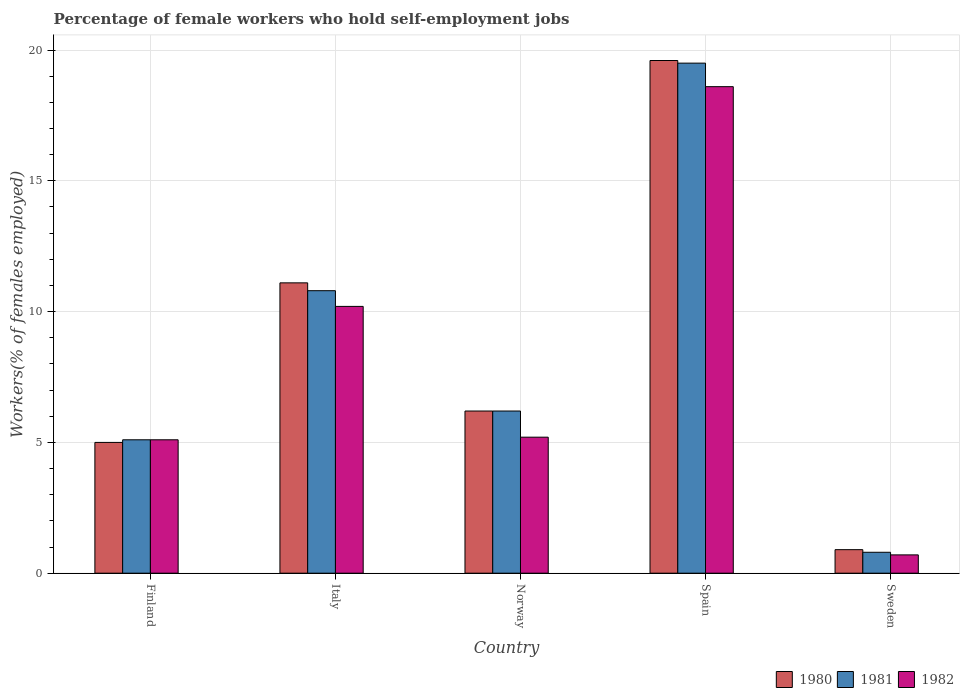How many different coloured bars are there?
Ensure brevity in your answer.  3. How many groups of bars are there?
Keep it short and to the point. 5. Are the number of bars on each tick of the X-axis equal?
Your response must be concise. Yes. How many bars are there on the 5th tick from the right?
Offer a very short reply. 3. What is the percentage of self-employed female workers in 1980 in Italy?
Your answer should be very brief. 11.1. Across all countries, what is the maximum percentage of self-employed female workers in 1981?
Ensure brevity in your answer.  19.5. Across all countries, what is the minimum percentage of self-employed female workers in 1982?
Give a very brief answer. 0.7. What is the total percentage of self-employed female workers in 1981 in the graph?
Keep it short and to the point. 42.4. What is the difference between the percentage of self-employed female workers in 1981 in Finland and that in Sweden?
Your answer should be compact. 4.3. What is the difference between the percentage of self-employed female workers in 1982 in Italy and the percentage of self-employed female workers in 1981 in Sweden?
Keep it short and to the point. 9.4. What is the average percentage of self-employed female workers in 1980 per country?
Provide a short and direct response. 8.56. What is the difference between the percentage of self-employed female workers of/in 1982 and percentage of self-employed female workers of/in 1980 in Italy?
Provide a short and direct response. -0.9. What is the ratio of the percentage of self-employed female workers in 1981 in Norway to that in Spain?
Give a very brief answer. 0.32. What is the difference between the highest and the second highest percentage of self-employed female workers in 1981?
Your answer should be very brief. -8.7. What is the difference between the highest and the lowest percentage of self-employed female workers in 1982?
Offer a terse response. 17.9. In how many countries, is the percentage of self-employed female workers in 1981 greater than the average percentage of self-employed female workers in 1981 taken over all countries?
Give a very brief answer. 2. What does the 2nd bar from the right in Italy represents?
Provide a succinct answer. 1981. Is it the case that in every country, the sum of the percentage of self-employed female workers in 1981 and percentage of self-employed female workers in 1982 is greater than the percentage of self-employed female workers in 1980?
Ensure brevity in your answer.  Yes. How many bars are there?
Make the answer very short. 15. How many legend labels are there?
Your answer should be compact. 3. How are the legend labels stacked?
Provide a short and direct response. Horizontal. What is the title of the graph?
Provide a succinct answer. Percentage of female workers who hold self-employment jobs. What is the label or title of the Y-axis?
Your answer should be very brief. Workers(% of females employed). What is the Workers(% of females employed) in 1981 in Finland?
Keep it short and to the point. 5.1. What is the Workers(% of females employed) of 1982 in Finland?
Give a very brief answer. 5.1. What is the Workers(% of females employed) in 1980 in Italy?
Provide a short and direct response. 11.1. What is the Workers(% of females employed) in 1981 in Italy?
Your answer should be very brief. 10.8. What is the Workers(% of females employed) in 1982 in Italy?
Give a very brief answer. 10.2. What is the Workers(% of females employed) of 1980 in Norway?
Give a very brief answer. 6.2. What is the Workers(% of females employed) of 1981 in Norway?
Provide a short and direct response. 6.2. What is the Workers(% of females employed) in 1982 in Norway?
Keep it short and to the point. 5.2. What is the Workers(% of females employed) of 1980 in Spain?
Your answer should be compact. 19.6. What is the Workers(% of females employed) of 1981 in Spain?
Make the answer very short. 19.5. What is the Workers(% of females employed) in 1982 in Spain?
Offer a terse response. 18.6. What is the Workers(% of females employed) in 1980 in Sweden?
Provide a succinct answer. 0.9. What is the Workers(% of females employed) in 1981 in Sweden?
Your answer should be very brief. 0.8. What is the Workers(% of females employed) of 1982 in Sweden?
Offer a terse response. 0.7. Across all countries, what is the maximum Workers(% of females employed) in 1980?
Your response must be concise. 19.6. Across all countries, what is the maximum Workers(% of females employed) of 1982?
Give a very brief answer. 18.6. Across all countries, what is the minimum Workers(% of females employed) in 1980?
Offer a very short reply. 0.9. Across all countries, what is the minimum Workers(% of females employed) in 1981?
Give a very brief answer. 0.8. Across all countries, what is the minimum Workers(% of females employed) of 1982?
Give a very brief answer. 0.7. What is the total Workers(% of females employed) in 1980 in the graph?
Give a very brief answer. 42.8. What is the total Workers(% of females employed) in 1981 in the graph?
Your answer should be compact. 42.4. What is the total Workers(% of females employed) in 1982 in the graph?
Keep it short and to the point. 39.8. What is the difference between the Workers(% of females employed) of 1981 in Finland and that in Italy?
Offer a terse response. -5.7. What is the difference between the Workers(% of females employed) in 1982 in Finland and that in Italy?
Give a very brief answer. -5.1. What is the difference between the Workers(% of females employed) of 1980 in Finland and that in Norway?
Give a very brief answer. -1.2. What is the difference between the Workers(% of females employed) of 1982 in Finland and that in Norway?
Offer a very short reply. -0.1. What is the difference between the Workers(% of females employed) in 1980 in Finland and that in Spain?
Ensure brevity in your answer.  -14.6. What is the difference between the Workers(% of females employed) of 1981 in Finland and that in Spain?
Ensure brevity in your answer.  -14.4. What is the difference between the Workers(% of females employed) of 1982 in Finland and that in Spain?
Make the answer very short. -13.5. What is the difference between the Workers(% of females employed) in 1980 in Finland and that in Sweden?
Ensure brevity in your answer.  4.1. What is the difference between the Workers(% of females employed) in 1981 in Finland and that in Sweden?
Your answer should be very brief. 4.3. What is the difference between the Workers(% of females employed) of 1982 in Finland and that in Sweden?
Your response must be concise. 4.4. What is the difference between the Workers(% of females employed) of 1980 in Italy and that in Norway?
Keep it short and to the point. 4.9. What is the difference between the Workers(% of females employed) of 1981 in Italy and that in Spain?
Provide a succinct answer. -8.7. What is the difference between the Workers(% of females employed) in 1981 in Italy and that in Sweden?
Provide a succinct answer. 10. What is the difference between the Workers(% of females employed) of 1981 in Norway and that in Spain?
Provide a succinct answer. -13.3. What is the difference between the Workers(% of females employed) in 1981 in Norway and that in Sweden?
Offer a very short reply. 5.4. What is the difference between the Workers(% of females employed) in 1982 in Norway and that in Sweden?
Your response must be concise. 4.5. What is the difference between the Workers(% of females employed) in 1980 in Finland and the Workers(% of females employed) in 1981 in Italy?
Provide a short and direct response. -5.8. What is the difference between the Workers(% of females employed) of 1980 in Finland and the Workers(% of females employed) of 1981 in Norway?
Your response must be concise. -1.2. What is the difference between the Workers(% of females employed) in 1980 in Finland and the Workers(% of females employed) in 1982 in Norway?
Keep it short and to the point. -0.2. What is the difference between the Workers(% of females employed) of 1980 in Finland and the Workers(% of females employed) of 1981 in Spain?
Provide a succinct answer. -14.5. What is the difference between the Workers(% of females employed) of 1981 in Finland and the Workers(% of females employed) of 1982 in Spain?
Make the answer very short. -13.5. What is the difference between the Workers(% of females employed) of 1981 in Finland and the Workers(% of females employed) of 1982 in Sweden?
Your answer should be very brief. 4.4. What is the difference between the Workers(% of females employed) of 1980 in Italy and the Workers(% of females employed) of 1981 in Norway?
Your response must be concise. 4.9. What is the difference between the Workers(% of females employed) of 1980 in Italy and the Workers(% of females employed) of 1982 in Norway?
Give a very brief answer. 5.9. What is the difference between the Workers(% of females employed) of 1980 in Italy and the Workers(% of females employed) of 1982 in Spain?
Your answer should be very brief. -7.5. What is the difference between the Workers(% of females employed) in 1981 in Italy and the Workers(% of females employed) in 1982 in Spain?
Your answer should be compact. -7.8. What is the difference between the Workers(% of females employed) in 1981 in Italy and the Workers(% of females employed) in 1982 in Sweden?
Your answer should be very brief. 10.1. What is the difference between the Workers(% of females employed) of 1980 in Norway and the Workers(% of females employed) of 1981 in Spain?
Ensure brevity in your answer.  -13.3. What is the difference between the Workers(% of females employed) in 1980 in Norway and the Workers(% of females employed) in 1981 in Sweden?
Offer a terse response. 5.4. What is the difference between the Workers(% of females employed) of 1980 in Norway and the Workers(% of females employed) of 1982 in Sweden?
Offer a terse response. 5.5. What is the difference between the Workers(% of females employed) in 1981 in Norway and the Workers(% of females employed) in 1982 in Sweden?
Make the answer very short. 5.5. What is the difference between the Workers(% of females employed) in 1981 in Spain and the Workers(% of females employed) in 1982 in Sweden?
Give a very brief answer. 18.8. What is the average Workers(% of females employed) in 1980 per country?
Keep it short and to the point. 8.56. What is the average Workers(% of females employed) in 1981 per country?
Ensure brevity in your answer.  8.48. What is the average Workers(% of females employed) of 1982 per country?
Your answer should be compact. 7.96. What is the difference between the Workers(% of females employed) in 1981 and Workers(% of females employed) in 1982 in Finland?
Provide a short and direct response. 0. What is the difference between the Workers(% of females employed) in 1980 and Workers(% of females employed) in 1981 in Italy?
Provide a succinct answer. 0.3. What is the difference between the Workers(% of females employed) of 1980 and Workers(% of females employed) of 1982 in Norway?
Offer a terse response. 1. What is the difference between the Workers(% of females employed) in 1980 and Workers(% of females employed) in 1982 in Spain?
Provide a short and direct response. 1. What is the difference between the Workers(% of females employed) of 1980 and Workers(% of females employed) of 1981 in Sweden?
Ensure brevity in your answer.  0.1. What is the difference between the Workers(% of females employed) of 1981 and Workers(% of females employed) of 1982 in Sweden?
Your answer should be very brief. 0.1. What is the ratio of the Workers(% of females employed) of 1980 in Finland to that in Italy?
Provide a succinct answer. 0.45. What is the ratio of the Workers(% of females employed) of 1981 in Finland to that in Italy?
Provide a short and direct response. 0.47. What is the ratio of the Workers(% of females employed) of 1982 in Finland to that in Italy?
Provide a succinct answer. 0.5. What is the ratio of the Workers(% of females employed) of 1980 in Finland to that in Norway?
Keep it short and to the point. 0.81. What is the ratio of the Workers(% of females employed) in 1981 in Finland to that in Norway?
Provide a short and direct response. 0.82. What is the ratio of the Workers(% of females employed) in 1982 in Finland to that in Norway?
Offer a very short reply. 0.98. What is the ratio of the Workers(% of females employed) in 1980 in Finland to that in Spain?
Your answer should be compact. 0.26. What is the ratio of the Workers(% of females employed) in 1981 in Finland to that in Spain?
Provide a succinct answer. 0.26. What is the ratio of the Workers(% of females employed) in 1982 in Finland to that in Spain?
Your answer should be very brief. 0.27. What is the ratio of the Workers(% of females employed) of 1980 in Finland to that in Sweden?
Make the answer very short. 5.56. What is the ratio of the Workers(% of females employed) in 1981 in Finland to that in Sweden?
Your answer should be very brief. 6.38. What is the ratio of the Workers(% of females employed) in 1982 in Finland to that in Sweden?
Provide a short and direct response. 7.29. What is the ratio of the Workers(% of females employed) of 1980 in Italy to that in Norway?
Your answer should be compact. 1.79. What is the ratio of the Workers(% of females employed) of 1981 in Italy to that in Norway?
Make the answer very short. 1.74. What is the ratio of the Workers(% of females employed) of 1982 in Italy to that in Norway?
Ensure brevity in your answer.  1.96. What is the ratio of the Workers(% of females employed) of 1980 in Italy to that in Spain?
Offer a terse response. 0.57. What is the ratio of the Workers(% of females employed) of 1981 in Italy to that in Spain?
Provide a short and direct response. 0.55. What is the ratio of the Workers(% of females employed) in 1982 in Italy to that in Spain?
Keep it short and to the point. 0.55. What is the ratio of the Workers(% of females employed) of 1980 in Italy to that in Sweden?
Offer a very short reply. 12.33. What is the ratio of the Workers(% of females employed) of 1982 in Italy to that in Sweden?
Your answer should be very brief. 14.57. What is the ratio of the Workers(% of females employed) in 1980 in Norway to that in Spain?
Ensure brevity in your answer.  0.32. What is the ratio of the Workers(% of females employed) of 1981 in Norway to that in Spain?
Provide a succinct answer. 0.32. What is the ratio of the Workers(% of females employed) of 1982 in Norway to that in Spain?
Make the answer very short. 0.28. What is the ratio of the Workers(% of females employed) of 1980 in Norway to that in Sweden?
Give a very brief answer. 6.89. What is the ratio of the Workers(% of females employed) in 1981 in Norway to that in Sweden?
Make the answer very short. 7.75. What is the ratio of the Workers(% of females employed) in 1982 in Norway to that in Sweden?
Your response must be concise. 7.43. What is the ratio of the Workers(% of females employed) in 1980 in Spain to that in Sweden?
Make the answer very short. 21.78. What is the ratio of the Workers(% of females employed) in 1981 in Spain to that in Sweden?
Provide a succinct answer. 24.38. What is the ratio of the Workers(% of females employed) in 1982 in Spain to that in Sweden?
Your answer should be very brief. 26.57. What is the difference between the highest and the lowest Workers(% of females employed) of 1981?
Give a very brief answer. 18.7. 